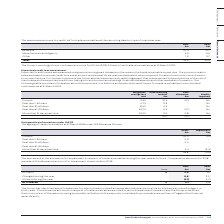According to Auto Trader's financial document, What information does the table provide? The maximum exposure to credit risk for trade receivables at the reporting date by type of customer. The document states: "The maximum exposure to credit risk for trade receivables at the reporting date by type of customer was:..." Also, How much did the Group's most significant customer account for? £0.5m (2018: £0.6m) of net trade receivables. The document states: "The Group’s most significant customer accounts for £0.5m (2018: £0.6m) of net trade receivables as at 31 March 2019...." Also, What were the components making up the maximum exposure to credit risk for trade receivables at the reporting date by type of customer? The document contains multiple relevant values: Retailers, Manufacturer and Agency, Other. From the document: "Retailers 20.4 21.7 Other 1.3 0.7 Manufacturer and Agency 3.2 3.0..." Additionally, In which year was the amount of Other larger? According to the financial document, 2019. The relevant text states: "2019 £m 2018 £m..." Also, can you calculate: What was the change in Other in 2019 from 2018? Based on the calculation: 1.3-0.7, the result is 0.6 (in millions). This is based on the information: "Other 1.3 0.7 Other 1.3 0.7..." The key data points involved are: 0.7, 1.3. Also, can you calculate: What was the percentage change in Other in 2019 from 2018? To answer this question, I need to perform calculations using the financial data. The calculation is: (1.3-0.7)/0.7, which equals 85.71 (percentage). This is based on the information: "Other 1.3 0.7 Other 1.3 0.7..." The key data points involved are: 0.7, 1.3. 